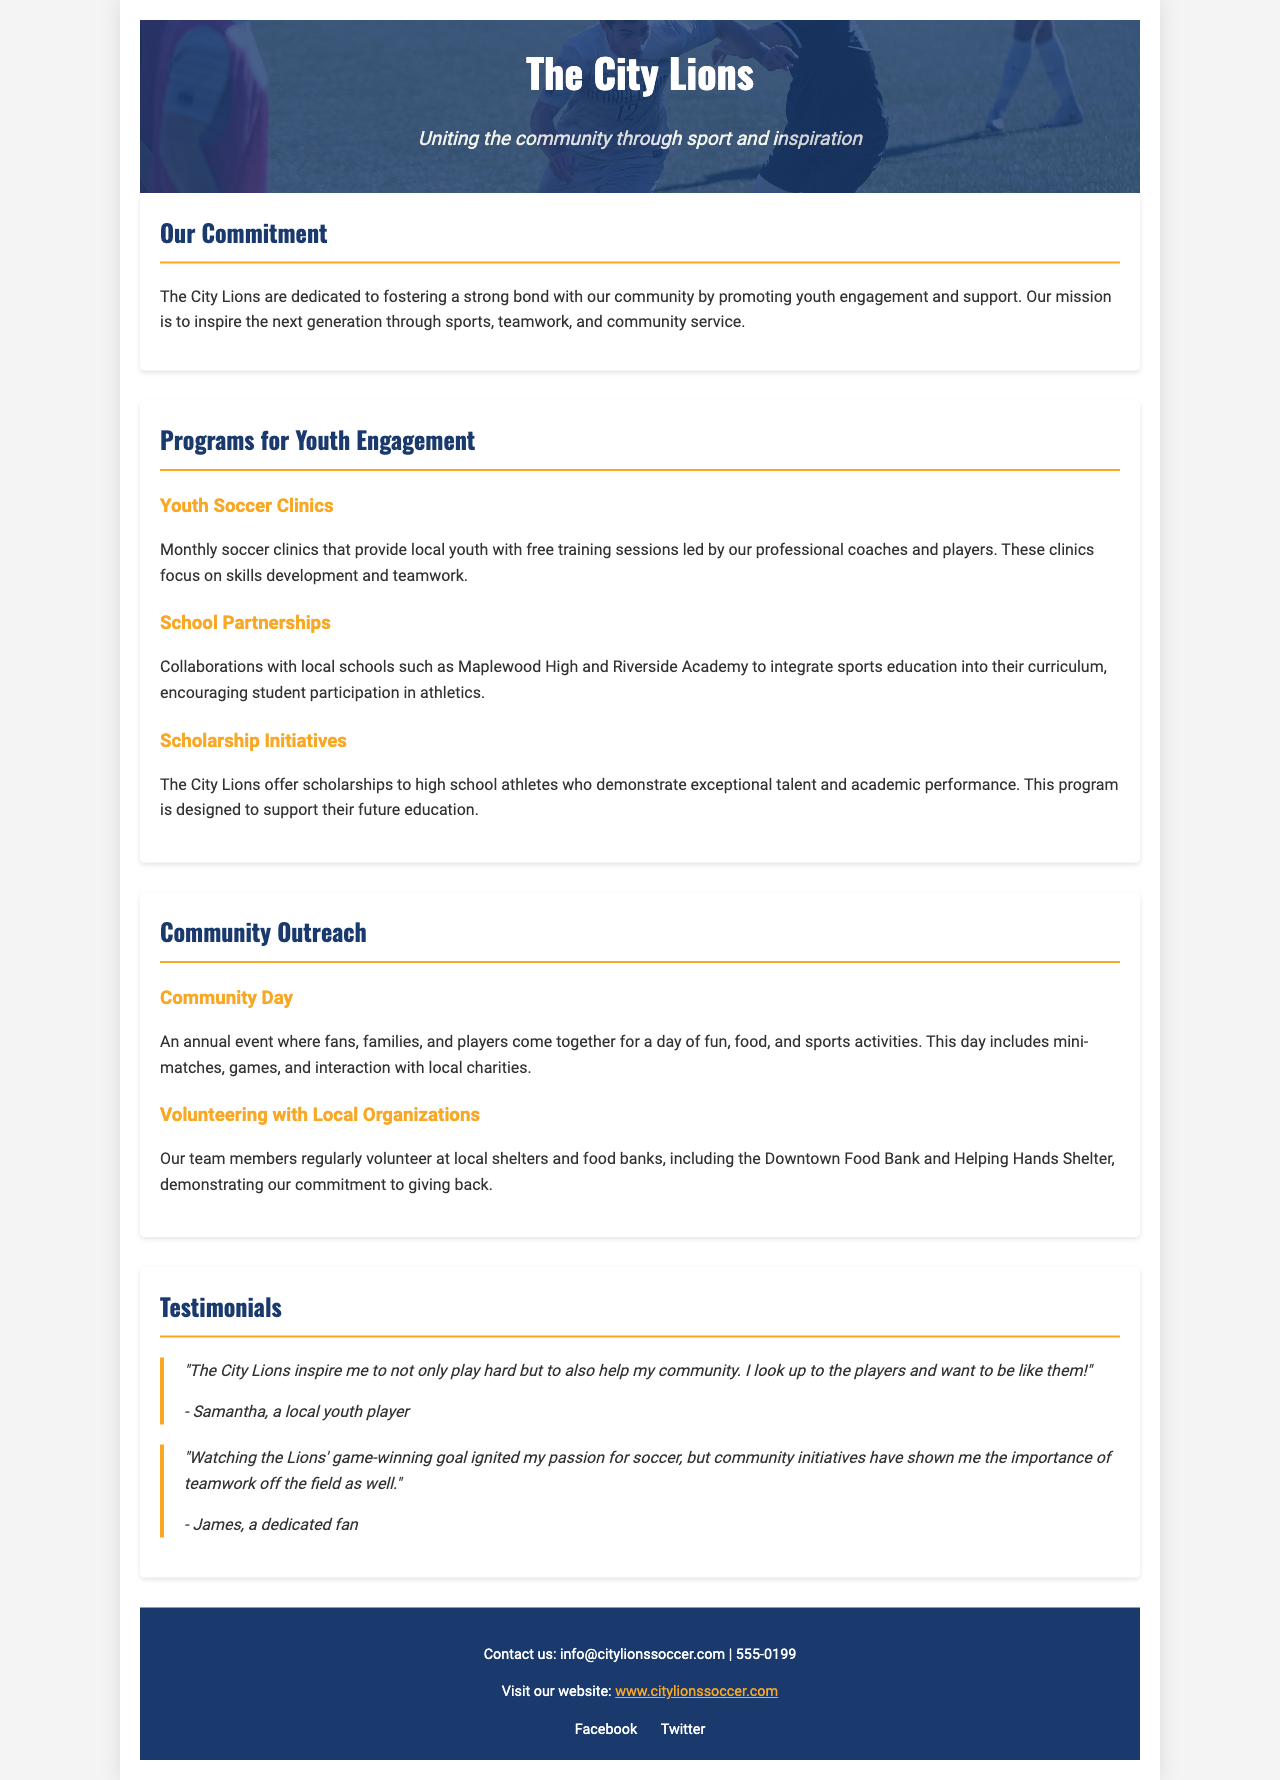What is the team's primary mission? The document states that the City Lions' mission is to inspire the next generation through sports, teamwork, and community service.
Answer: to inspire the next generation through sports, teamwork, and community service How often are the youth soccer clinics held? The brochure indicates that the soccer clinics are monthly, providing free training sessions.
Answer: monthly Which local schools are mentioned in the partnerships? The document lists Maplewood High and Riverside Academy as schools in collaboration.
Answer: Maplewood High and Riverside Academy What type of event is held annually? The document describes Community Day as an annual event where fans, families, and players gather.
Answer: Community Day How do the City Lions support talented high school athletes? The document explains that scholarships are offered to high school athletes with exceptional talent and academic performance.
Answer: scholarships What is a key purpose of the Community Day event? The event includes fun, food, and sports activities, uniting fans, families, and players.
Answer: a day of fun, food, and sports activities Who is a local youth player that provided a testimonial? The testimonial section includes a comment from Samantha, a local youth player.
Answer: Samantha Which local organizations do team members volunteer with? The document mentions the Downtown Food Bank and Helping Hands Shelter as organizations where team members volunteer.
Answer: Downtown Food Bank and Helping Hands Shelter What color represents the City Lions? The team uses a specific color scheme, prominently featuring blue and gold in the document.
Answer: blue and gold 